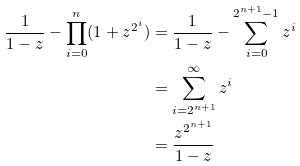<formula> <loc_0><loc_0><loc_500><loc_500>\frac { 1 } { 1 - z } - \prod _ { i = 0 } ^ { n } ( 1 + z ^ { 2 ^ { i } } ) & = \frac { 1 } { 1 - z } - \sum _ { i = 0 } ^ { 2 ^ { n + 1 } - 1 } z ^ { i } \\ & = \sum _ { i = 2 ^ { n + 1 } } ^ { \infty } z ^ { i } \\ & = \frac { z ^ { 2 ^ { n + 1 } } } { 1 - z }</formula> 